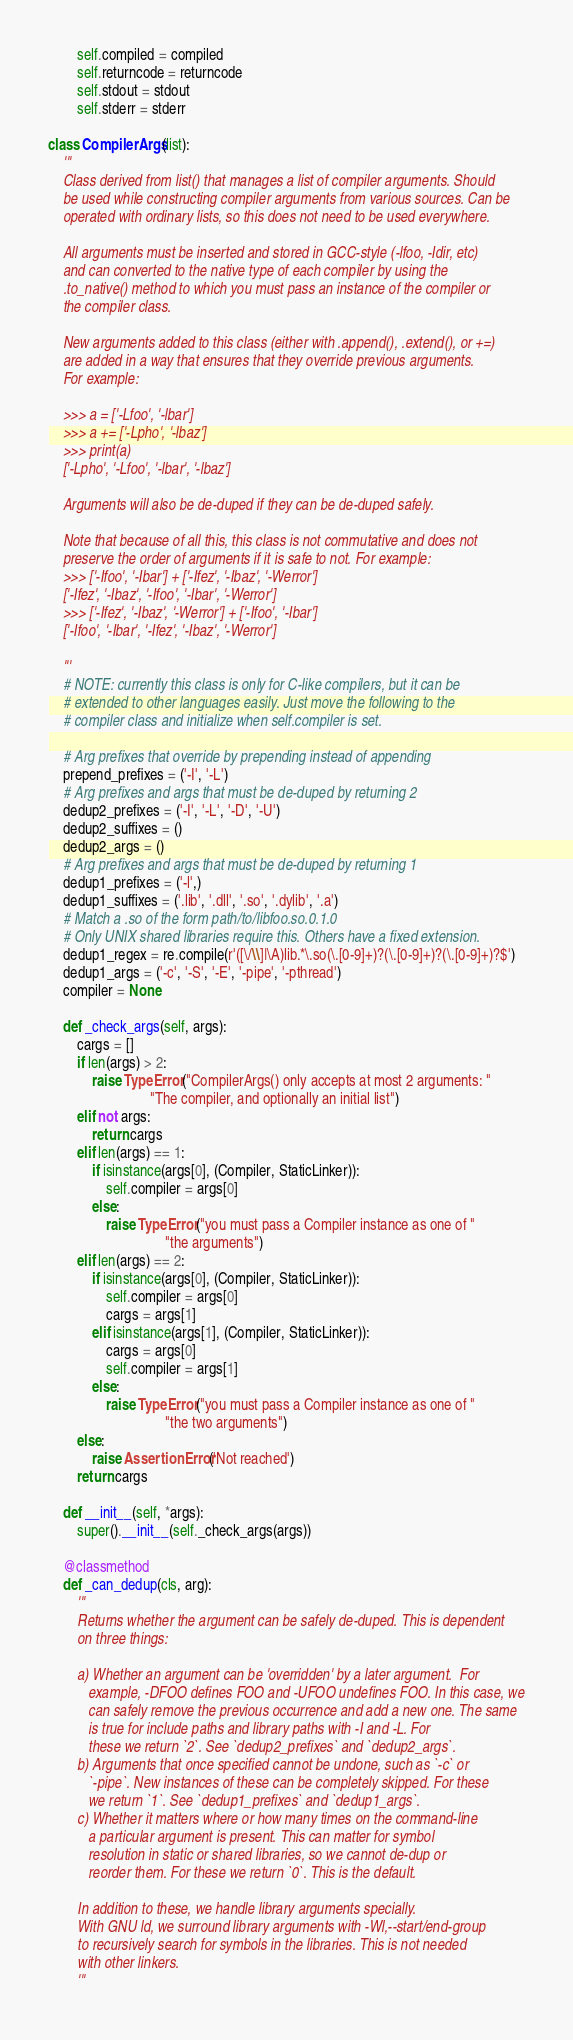Convert code to text. <code><loc_0><loc_0><loc_500><loc_500><_Python_>        self.compiled = compiled
        self.returncode = returncode
        self.stdout = stdout
        self.stderr = stderr

class CompilerArgs(list):
    '''
    Class derived from list() that manages a list of compiler arguments. Should
    be used while constructing compiler arguments from various sources. Can be
    operated with ordinary lists, so this does not need to be used everywhere.

    All arguments must be inserted and stored in GCC-style (-lfoo, -Idir, etc)
    and can converted to the native type of each compiler by using the
    .to_native() method to which you must pass an instance of the compiler or
    the compiler class.

    New arguments added to this class (either with .append(), .extend(), or +=)
    are added in a way that ensures that they override previous arguments.
    For example:

    >>> a = ['-Lfoo', '-lbar']
    >>> a += ['-Lpho', '-lbaz']
    >>> print(a)
    ['-Lpho', '-Lfoo', '-lbar', '-lbaz']

    Arguments will also be de-duped if they can be de-duped safely.

    Note that because of all this, this class is not commutative and does not
    preserve the order of arguments if it is safe to not. For example:
    >>> ['-Ifoo', '-Ibar'] + ['-Ifez', '-Ibaz', '-Werror']
    ['-Ifez', '-Ibaz', '-Ifoo', '-Ibar', '-Werror']
    >>> ['-Ifez', '-Ibaz', '-Werror'] + ['-Ifoo', '-Ibar']
    ['-Ifoo', '-Ibar', '-Ifez', '-Ibaz', '-Werror']

    '''
    # NOTE: currently this class is only for C-like compilers, but it can be
    # extended to other languages easily. Just move the following to the
    # compiler class and initialize when self.compiler is set.

    # Arg prefixes that override by prepending instead of appending
    prepend_prefixes = ('-I', '-L')
    # Arg prefixes and args that must be de-duped by returning 2
    dedup2_prefixes = ('-I', '-L', '-D', '-U')
    dedup2_suffixes = ()
    dedup2_args = ()
    # Arg prefixes and args that must be de-duped by returning 1
    dedup1_prefixes = ('-l',)
    dedup1_suffixes = ('.lib', '.dll', '.so', '.dylib', '.a')
    # Match a .so of the form path/to/libfoo.so.0.1.0
    # Only UNIX shared libraries require this. Others have a fixed extension.
    dedup1_regex = re.compile(r'([\/\\]|\A)lib.*\.so(\.[0-9]+)?(\.[0-9]+)?(\.[0-9]+)?$')
    dedup1_args = ('-c', '-S', '-E', '-pipe', '-pthread')
    compiler = None

    def _check_args(self, args):
        cargs = []
        if len(args) > 2:
            raise TypeError("CompilerArgs() only accepts at most 2 arguments: "
                            "The compiler, and optionally an initial list")
        elif not args:
            return cargs
        elif len(args) == 1:
            if isinstance(args[0], (Compiler, StaticLinker)):
                self.compiler = args[0]
            else:
                raise TypeError("you must pass a Compiler instance as one of "
                                "the arguments")
        elif len(args) == 2:
            if isinstance(args[0], (Compiler, StaticLinker)):
                self.compiler = args[0]
                cargs = args[1]
            elif isinstance(args[1], (Compiler, StaticLinker)):
                cargs = args[0]
                self.compiler = args[1]
            else:
                raise TypeError("you must pass a Compiler instance as one of "
                                "the two arguments")
        else:
            raise AssertionError('Not reached')
        return cargs

    def __init__(self, *args):
        super().__init__(self._check_args(args))

    @classmethod
    def _can_dedup(cls, arg):
        '''
        Returns whether the argument can be safely de-duped. This is dependent
        on three things:

        a) Whether an argument can be 'overridden' by a later argument.  For
           example, -DFOO defines FOO and -UFOO undefines FOO. In this case, we
           can safely remove the previous occurrence and add a new one. The same
           is true for include paths and library paths with -I and -L. For
           these we return `2`. See `dedup2_prefixes` and `dedup2_args`.
        b) Arguments that once specified cannot be undone, such as `-c` or
           `-pipe`. New instances of these can be completely skipped. For these
           we return `1`. See `dedup1_prefixes` and `dedup1_args`.
        c) Whether it matters where or how many times on the command-line
           a particular argument is present. This can matter for symbol
           resolution in static or shared libraries, so we cannot de-dup or
           reorder them. For these we return `0`. This is the default.

        In addition to these, we handle library arguments specially.
        With GNU ld, we surround library arguments with -Wl,--start/end-group
        to recursively search for symbols in the libraries. This is not needed
        with other linkers.
        '''
</code> 